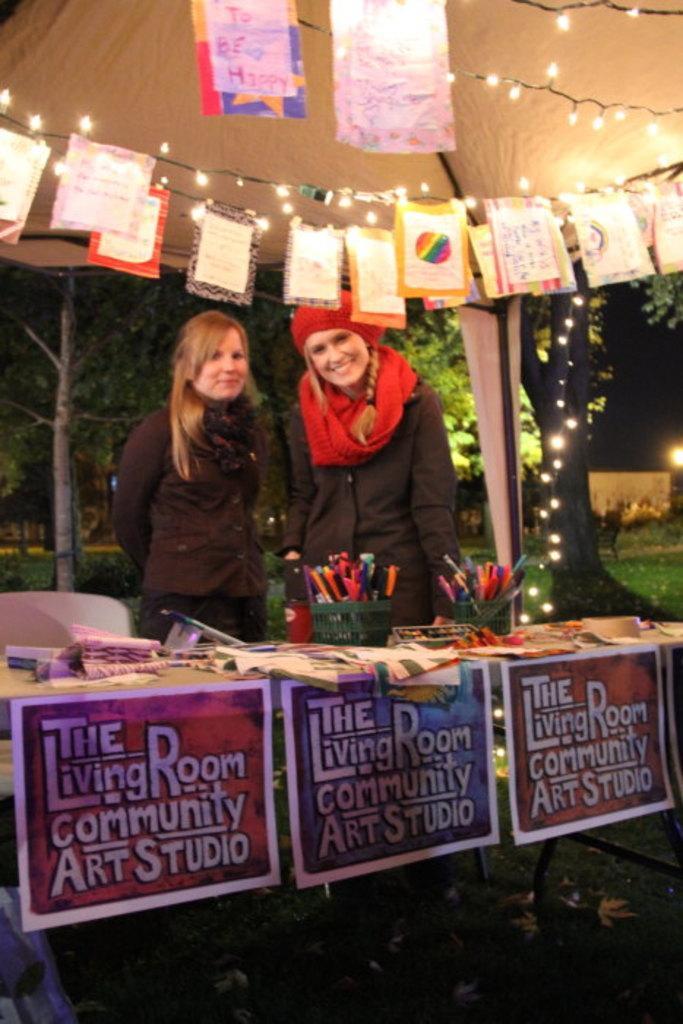Describe this image in one or two sentences. In this picture we can see 2 women standing on the grass under a tent. There are greeting cards above them. 